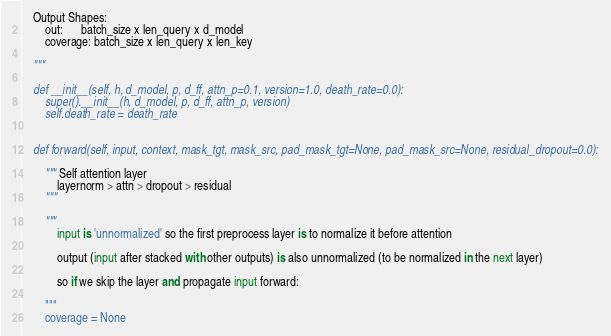Convert code to text. <code><loc_0><loc_0><loc_500><loc_500><_Python_>    Output Shapes:
        out:      batch_size x len_query x d_model
        coverage: batch_size x len_query x len_key
        
    """    
    
    def __init__(self, h, d_model, p, d_ff, attn_p=0.1, version=1.0, death_rate=0.0):
        super().__init__(h, d_model, p, d_ff, attn_p, version)
        self.death_rate = death_rate
        
    
    def forward(self, input, context, mask_tgt, mask_src, pad_mask_tgt=None, pad_mask_src=None, residual_dropout=0.0):
        
        """ Self attention layer 
            layernorm > attn > dropout > residual
        """
        
        """
            input is 'unnormalized' so the first preprocess layer is to normalize it before attention
            
            output (input after stacked with other outputs) is also unnormalized (to be normalized in the next layer)
            
            so if we skip the layer and propagate input forward:

        """
        coverage = None</code> 